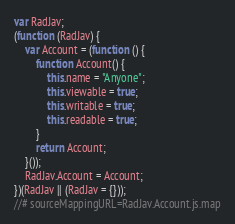<code> <loc_0><loc_0><loc_500><loc_500><_JavaScript_>var RadJav;
(function (RadJav) {
    var Account = (function () {
        function Account() {
            this.name = "Anyone";
            this.viewable = true;
            this.writable = true;
            this.readable = true;
        }
        return Account;
    }());
    RadJav.Account = Account;
})(RadJav || (RadJav = {}));
//# sourceMappingURL=RadJav.Account.js.map</code> 